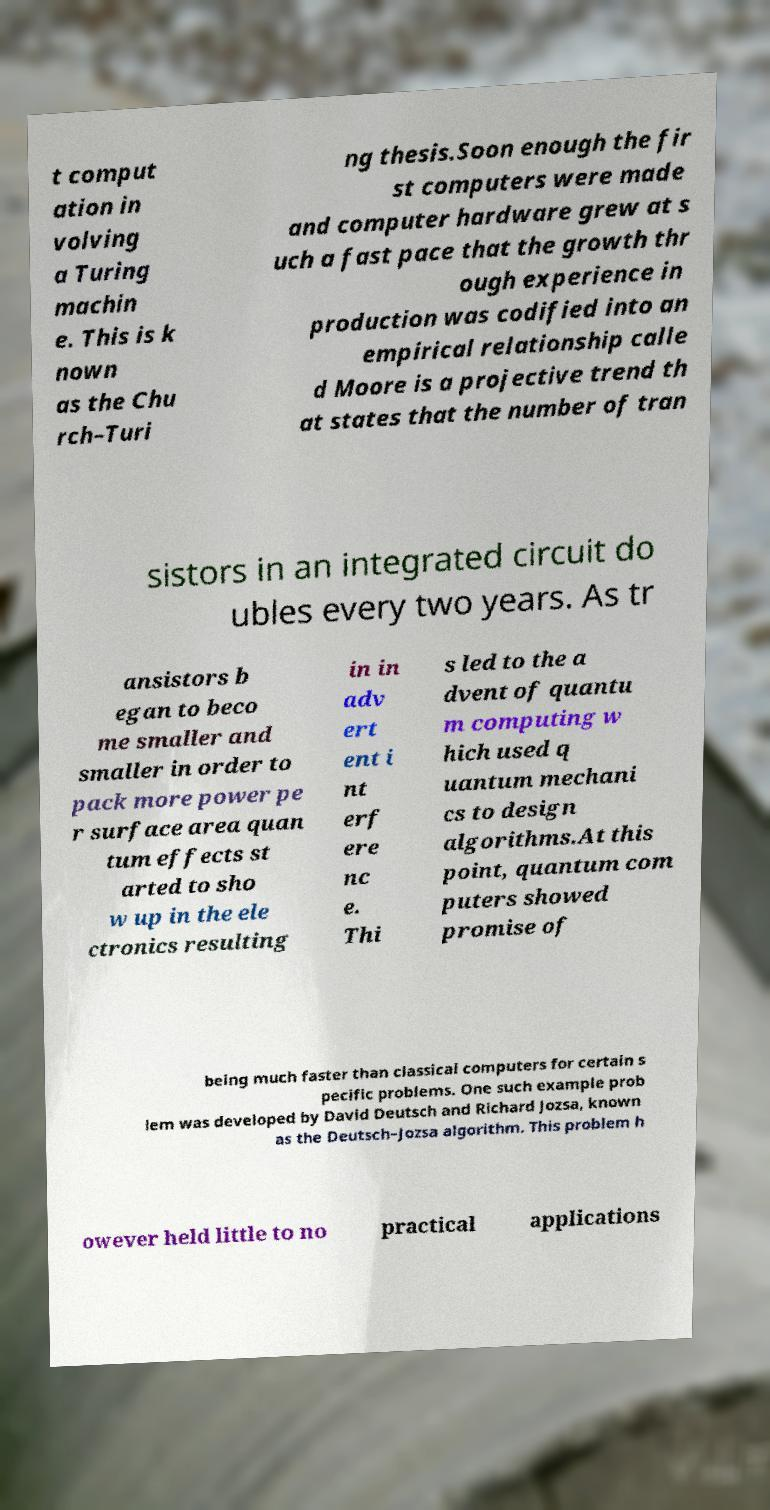Please identify and transcribe the text found in this image. t comput ation in volving a Turing machin e. This is k nown as the Chu rch–Turi ng thesis.Soon enough the fir st computers were made and computer hardware grew at s uch a fast pace that the growth thr ough experience in production was codified into an empirical relationship calle d Moore is a projective trend th at states that the number of tran sistors in an integrated circuit do ubles every two years. As tr ansistors b egan to beco me smaller and smaller in order to pack more power pe r surface area quan tum effects st arted to sho w up in the ele ctronics resulting in in adv ert ent i nt erf ere nc e. Thi s led to the a dvent of quantu m computing w hich used q uantum mechani cs to design algorithms.At this point, quantum com puters showed promise of being much faster than classical computers for certain s pecific problems. One such example prob lem was developed by David Deutsch and Richard Jozsa, known as the Deutsch–Jozsa algorithm. This problem h owever held little to no practical applications 